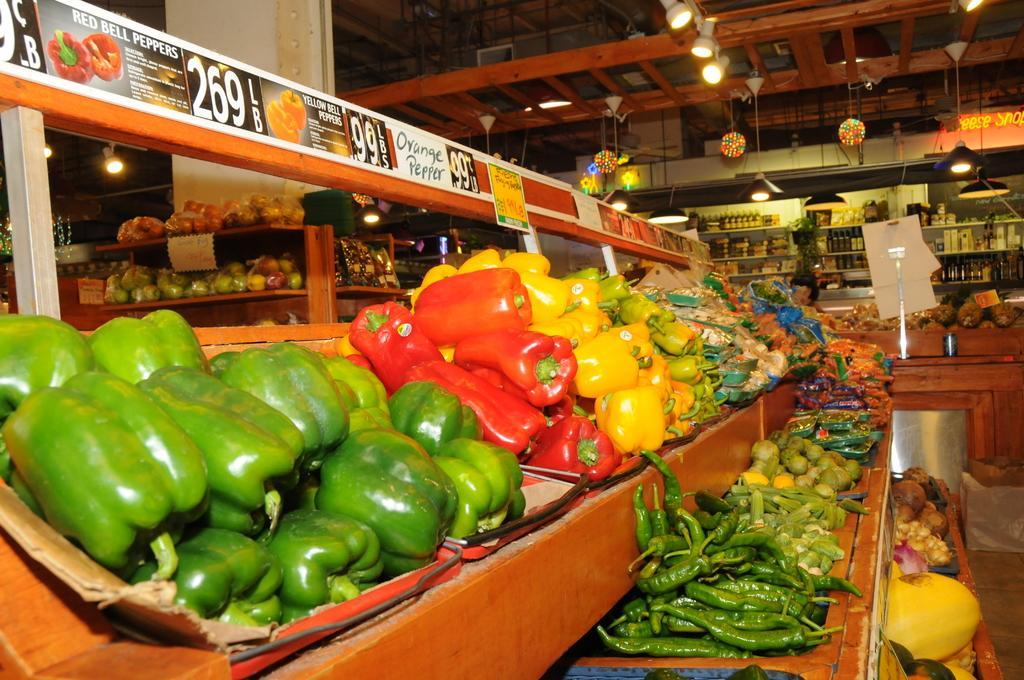How would you summarize this image in a sentence or two? In this image I can see many vegetables which are colorful. These are on the brown color surface. In the background I can see many boards, few more vegetables in the rack and also many objects can be seen in the racks. I can see the lights at the top. 